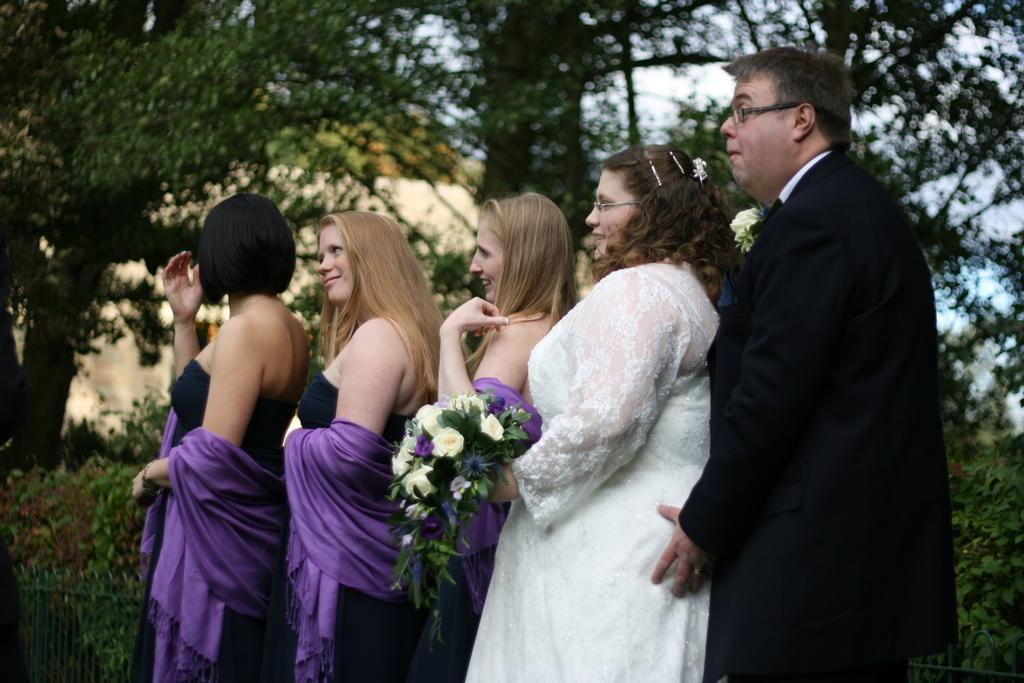What is happening in the image? There are people standing in the image. Can you describe the woman in the center of the image? A woman is holding a bouquet in the center of the image. What can be seen in the background of the image? There are trees, plants, and a building in the background of the image. How many robins are perched on the woman's bouquet in the image? There are no robins present in the image, so it is not possible to answer that question. 